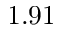<formula> <loc_0><loc_0><loc_500><loc_500>1 . 9 1</formula> 